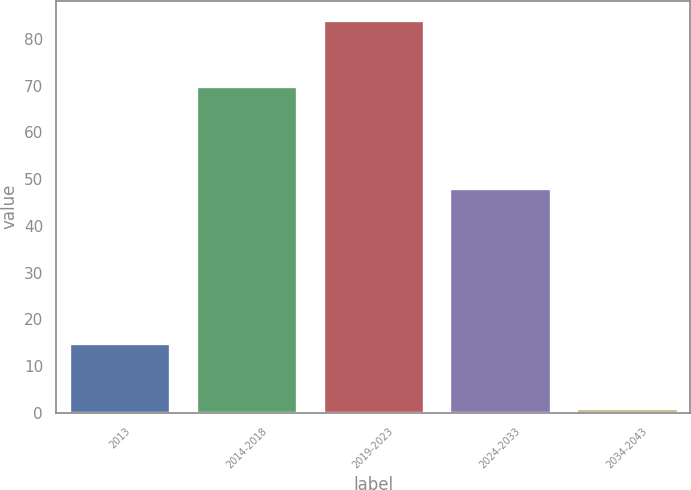Convert chart to OTSL. <chart><loc_0><loc_0><loc_500><loc_500><bar_chart><fcel>2013<fcel>2014-2018<fcel>2019-2023<fcel>2024-2033<fcel>2034-2043<nl><fcel>15<fcel>70<fcel>84<fcel>48<fcel>1<nl></chart> 